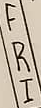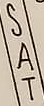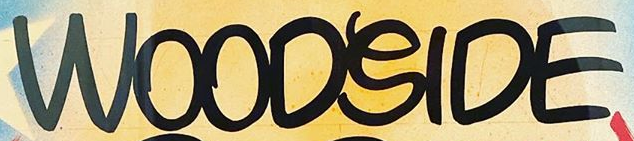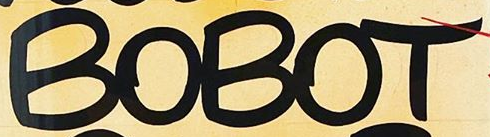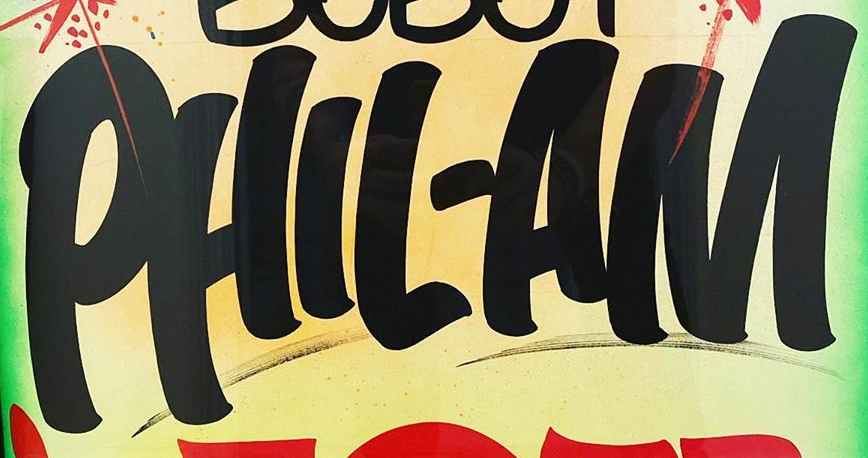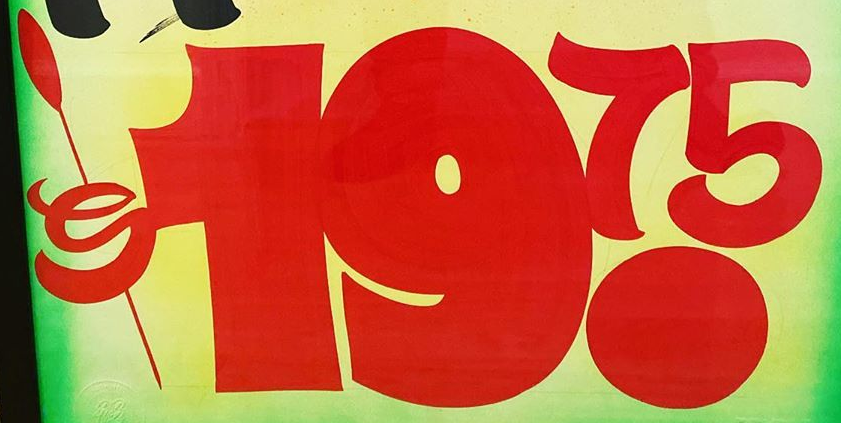Transcribe the words shown in these images in order, separated by a semicolon. FRI; SAT; WOODSIDE; BOBOT; PHIL-AM; $19.75 